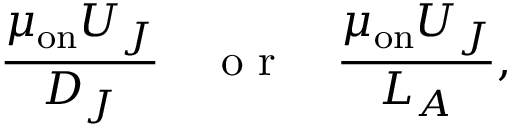Convert formula to latex. <formula><loc_0><loc_0><loc_500><loc_500>\frac { \mu _ { o n } U _ { J } } { D _ { J } } \quad o r \quad \frac { \mu _ { o n } U _ { J } } { L _ { A } } ,</formula> 